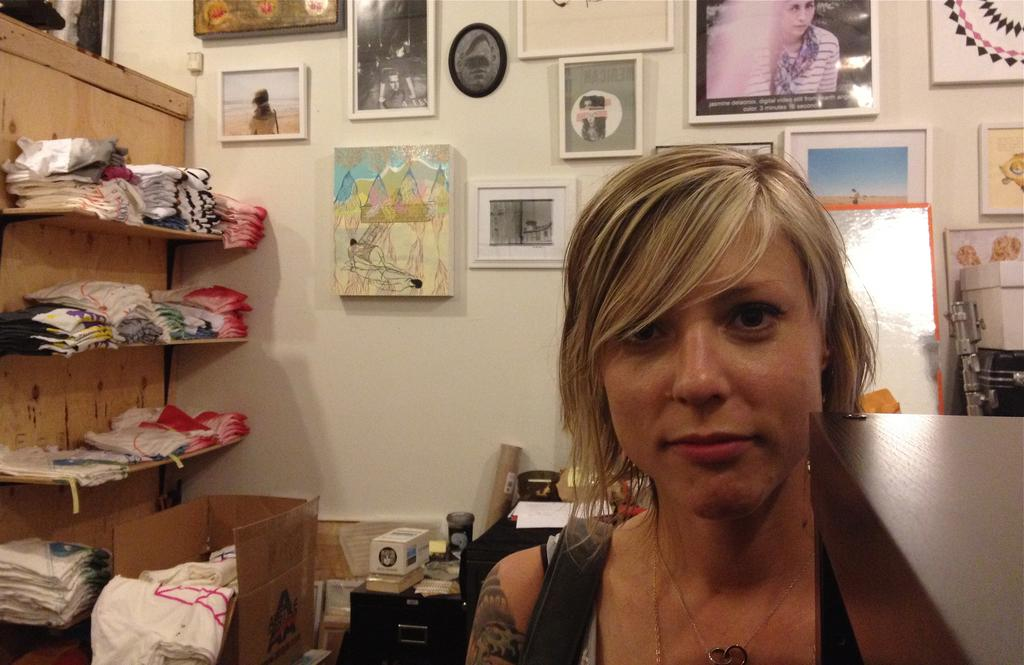Who is present in the image? There is a lady in the image. What can be seen in the background of the image? There are clothes on racks in the image. What is hanging on the wall in the image? There are photo frames on the wall in the image. What is on the table in the image? There are boxes on the table in the image. What type of pear is hanging from the wire in the image? There is no pear or wire present in the image. 